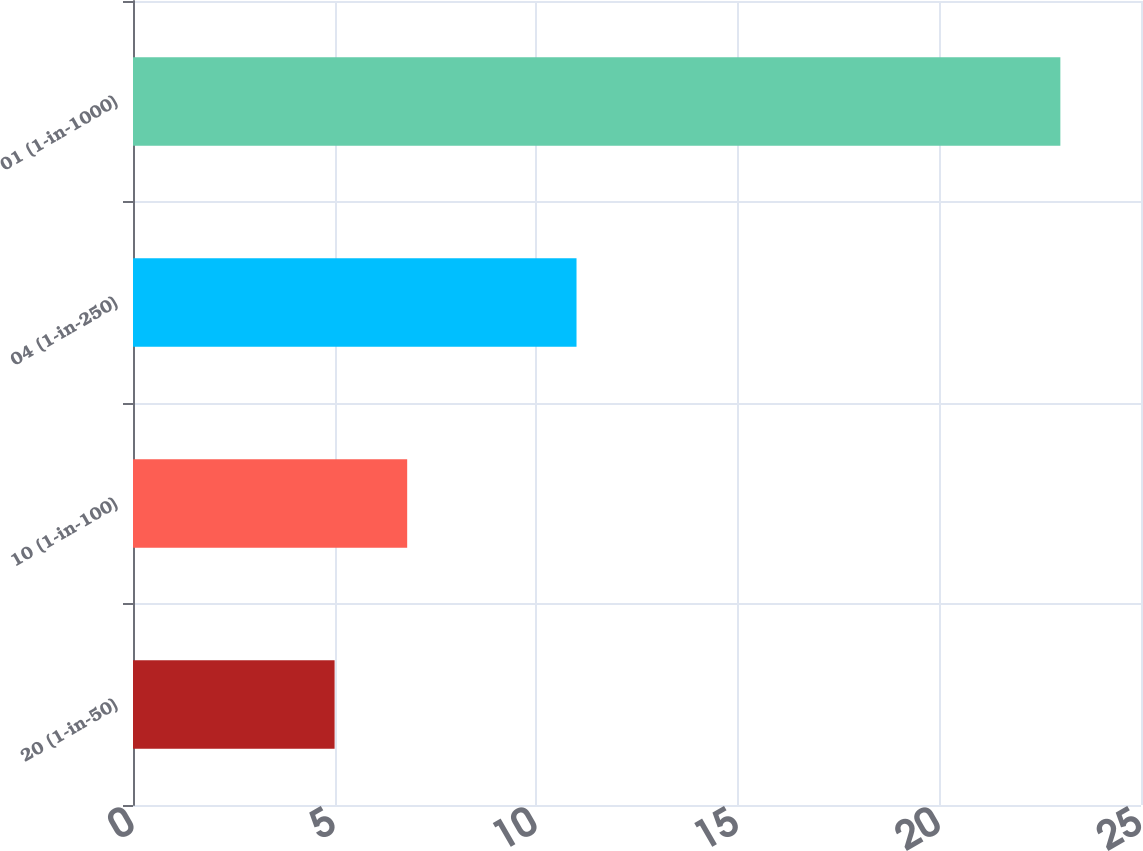Convert chart to OTSL. <chart><loc_0><loc_0><loc_500><loc_500><bar_chart><fcel>20 (1-in-50)<fcel>10 (1-in-100)<fcel>04 (1-in-250)<fcel>01 (1-in-1000)<nl><fcel>5<fcel>6.8<fcel>11<fcel>23<nl></chart> 